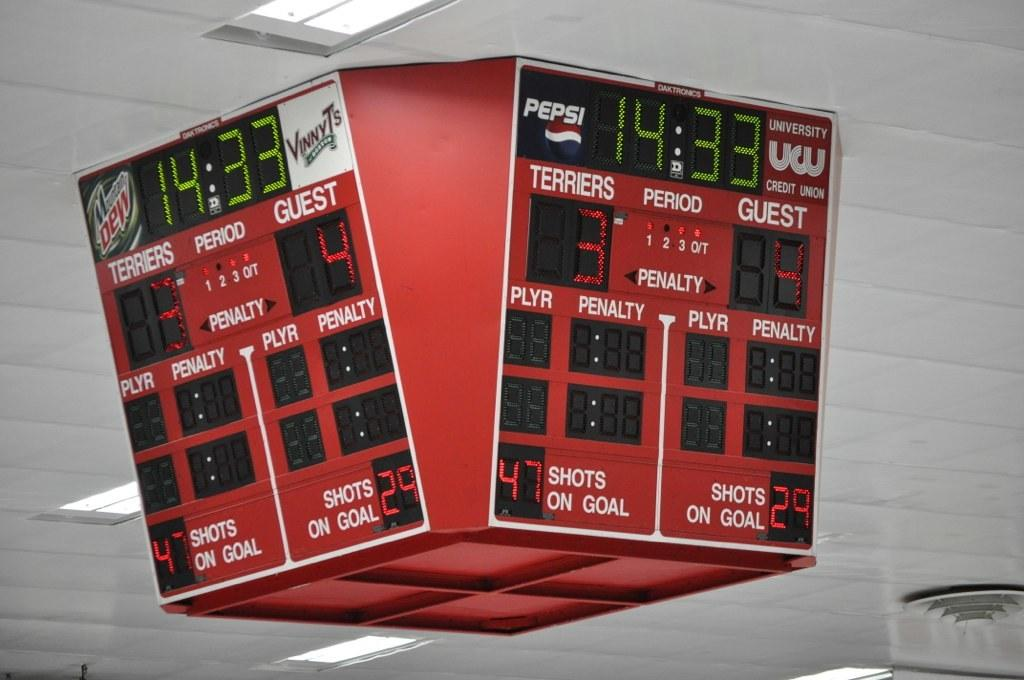<image>
Relay a brief, clear account of the picture shown. a sports arena score board reading Terriers 3 Guest 4 hangs from the ceiling 